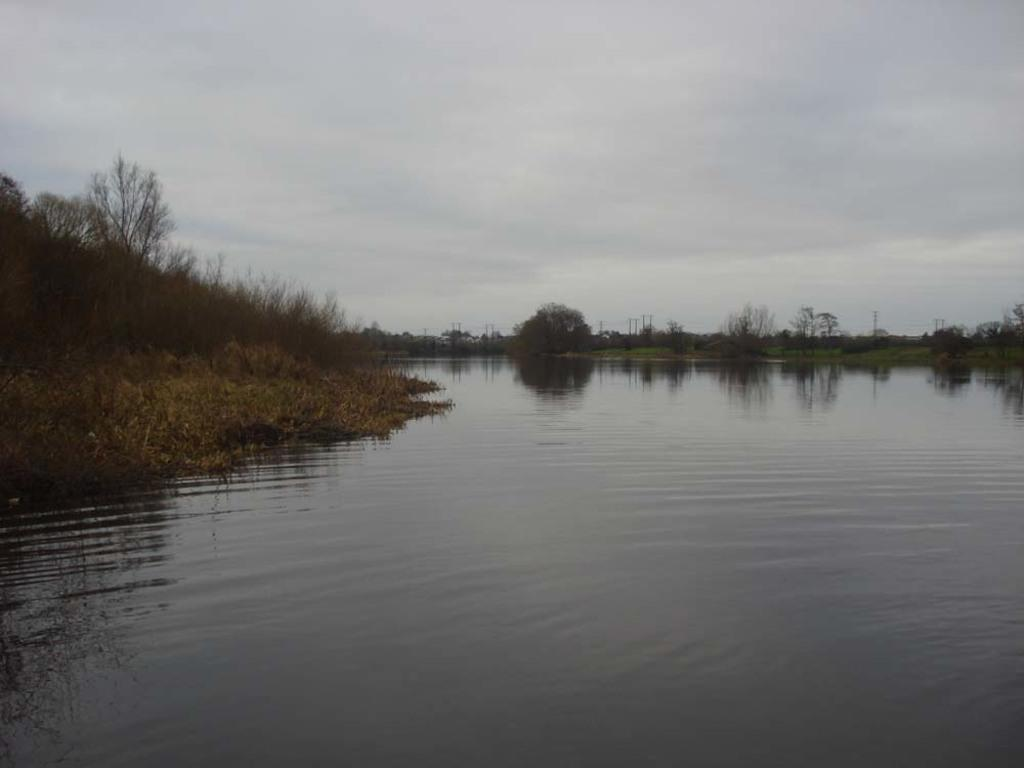What is the primary element visible in the image? There is water in the image. What type of vegetation can be seen in the image? There is grass and trees in the image. What part of the natural environment is visible in the background of the image? The sky is visible in the background of the image. What type of cushion is floating on the water in the image? There is no cushion present in the image; it only features water, grass, trees, and the sky. 